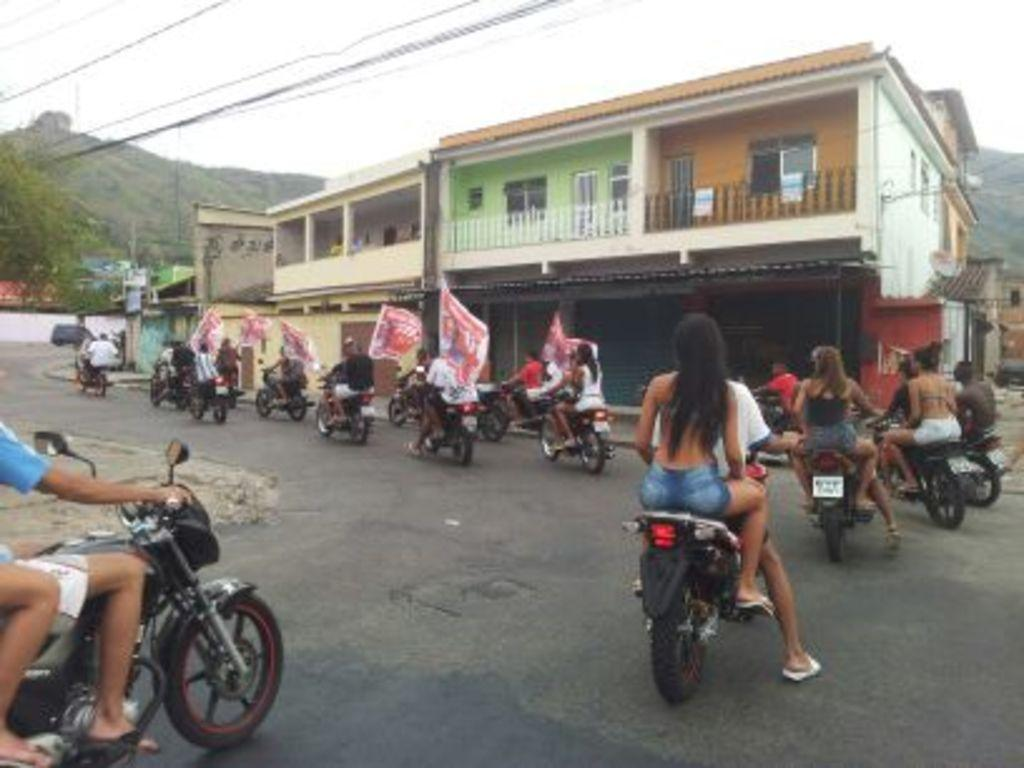What are the people in the image doing? The people in the image are riding bikes. Where are the bikes located? The bikes are on a road. What else can be seen in the image besides the people and bikes? There are houses and trees visible in the image. What type of cabbage is being harvested by the boy in the image? There is no boy or cabbage present in the image. What tool is the person using to dig in the image? There is no person using a spade or any digging tool in the image. 